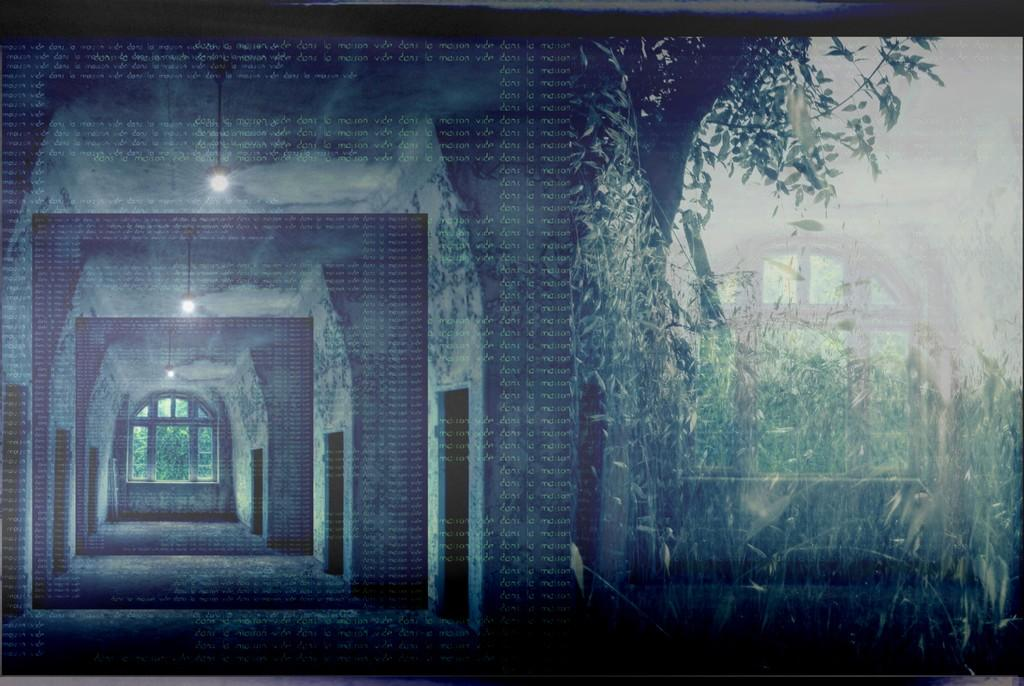What type of structures can be seen in the image? The image contains walls. What openings are present in the walls? There are windows in the image. What type of natural elements can be seen in the image? Trees are present in the image. What can be used for illumination in the image? There are lights visible in the image. Can you describe the tiger's digestion process in the image? There is no tiger present in the image, so it is not possible to describe its digestion process. 